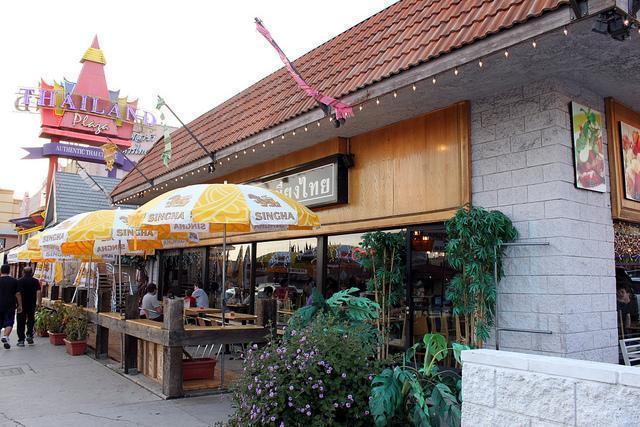What is the capital city of this country?
Choose the correct response and explain in the format: 'Answer: answer
Rationale: rationale.'
Options: Taipei, bangkok, tokyo, manila. Answer: bangkok.
Rationale: The capital is bangkok. 